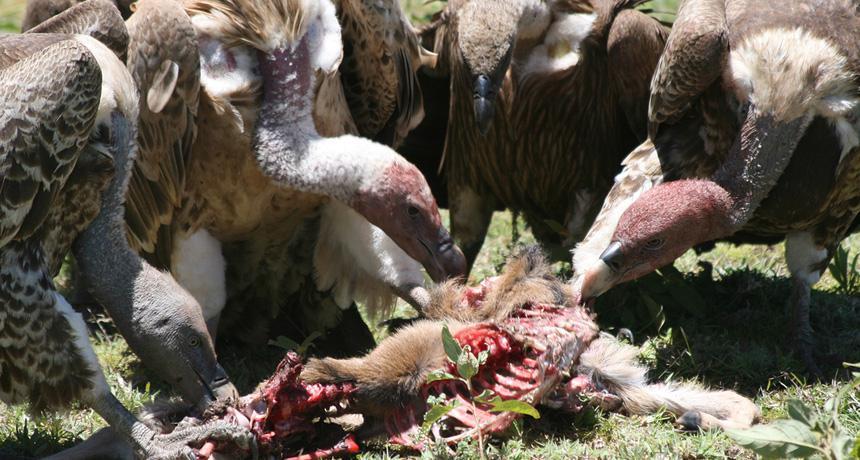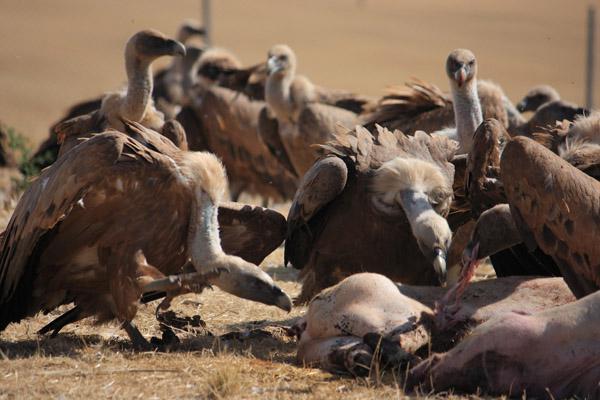The first image is the image on the left, the second image is the image on the right. Evaluate the accuracy of this statement regarding the images: "The carrion being eaten by the birds in the image on the left can be clearly seen.". Is it true? Answer yes or no. Yes. 